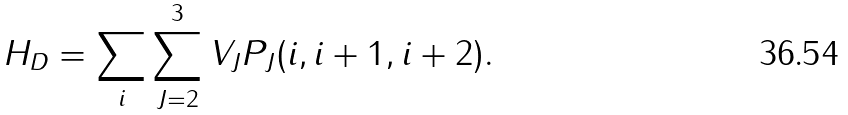<formula> <loc_0><loc_0><loc_500><loc_500>H _ { D } = \sum _ { i } \sum _ { J = 2 } ^ { 3 } V _ { J } P _ { J } ( i , i + 1 , i + 2 ) .</formula> 